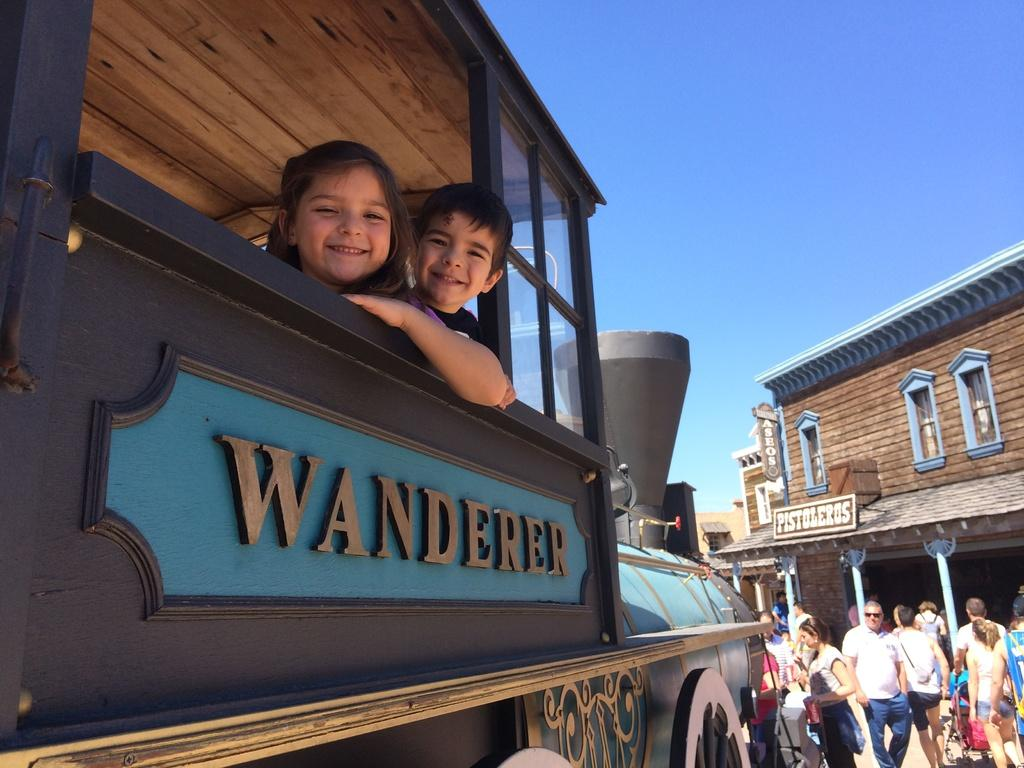What is the main subject of the image? The main subject of the image is a group of people. What else can be seen in the image besides the group of people? There is a vehicle, two children in the vehicle, buildings, and the sky visible in the image. What historical event is being commemorated by the group of people in the image? There is no indication of a historical event being commemorated in the image. 